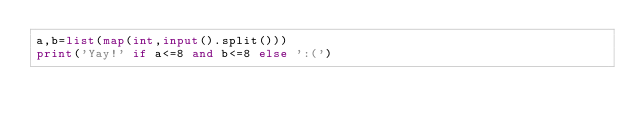Convert code to text. <code><loc_0><loc_0><loc_500><loc_500><_Python_>a,b=list(map(int,input().split()))
print('Yay!' if a<=8 and b<=8 else ':(')</code> 